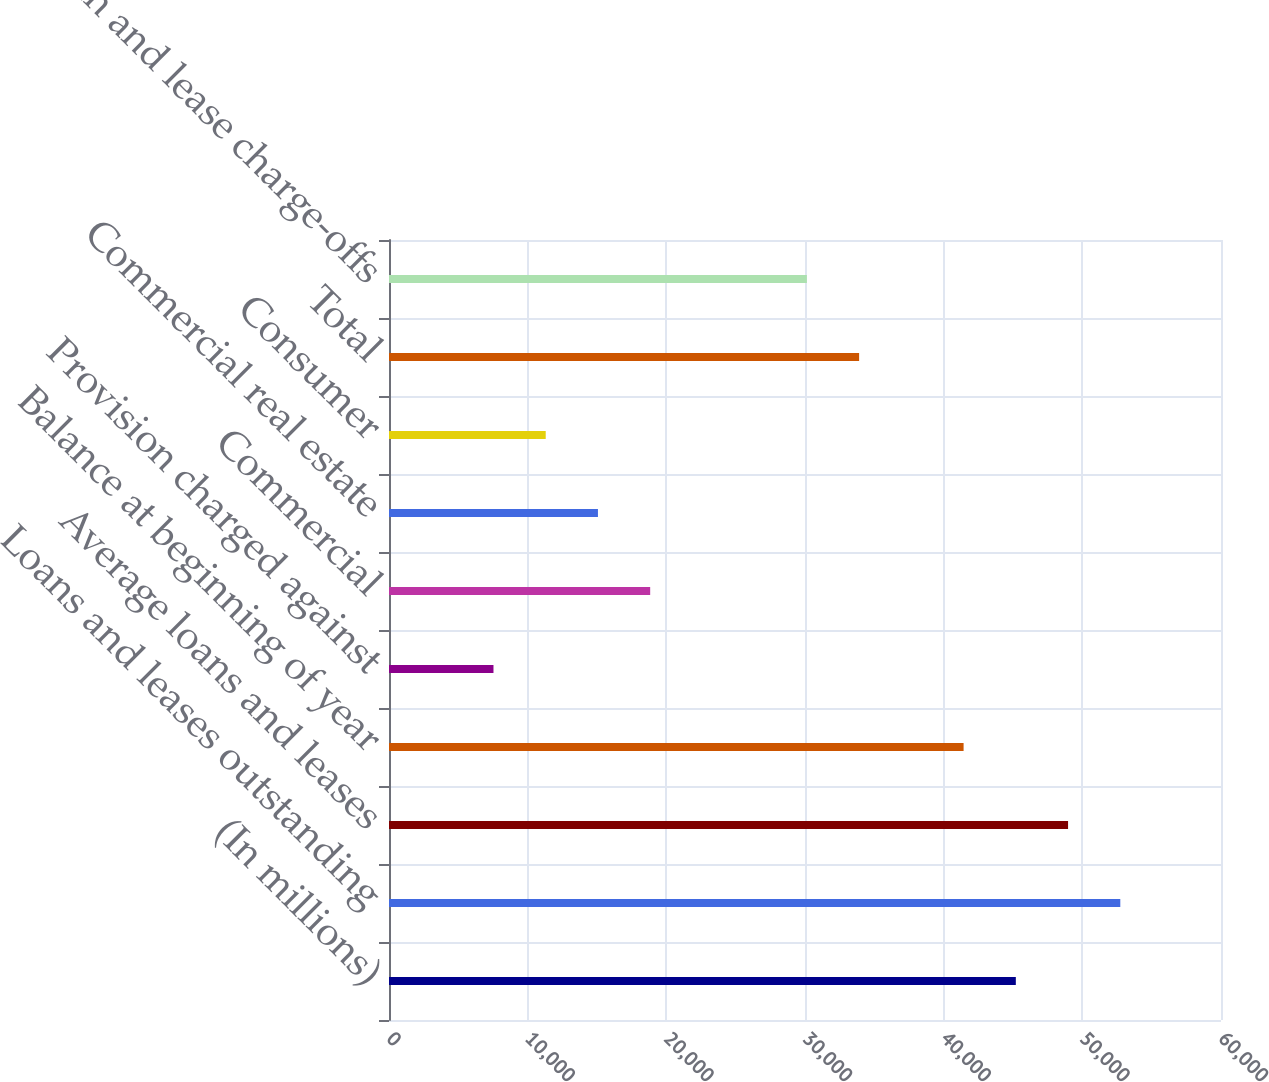Convert chart to OTSL. <chart><loc_0><loc_0><loc_500><loc_500><bar_chart><fcel>(In millions)<fcel>Loans and leases outstanding<fcel>Average loans and leases<fcel>Balance at beginning of year<fcel>Provision charged against<fcel>Commercial<fcel>Commercial real estate<fcel>Consumer<fcel>Total<fcel>Net loan and lease charge-offs<nl><fcel>45203.9<fcel>52737.9<fcel>48970.9<fcel>41437<fcel>7534.34<fcel>18835.2<fcel>15068.3<fcel>11301.3<fcel>33903.1<fcel>30136.1<nl></chart> 